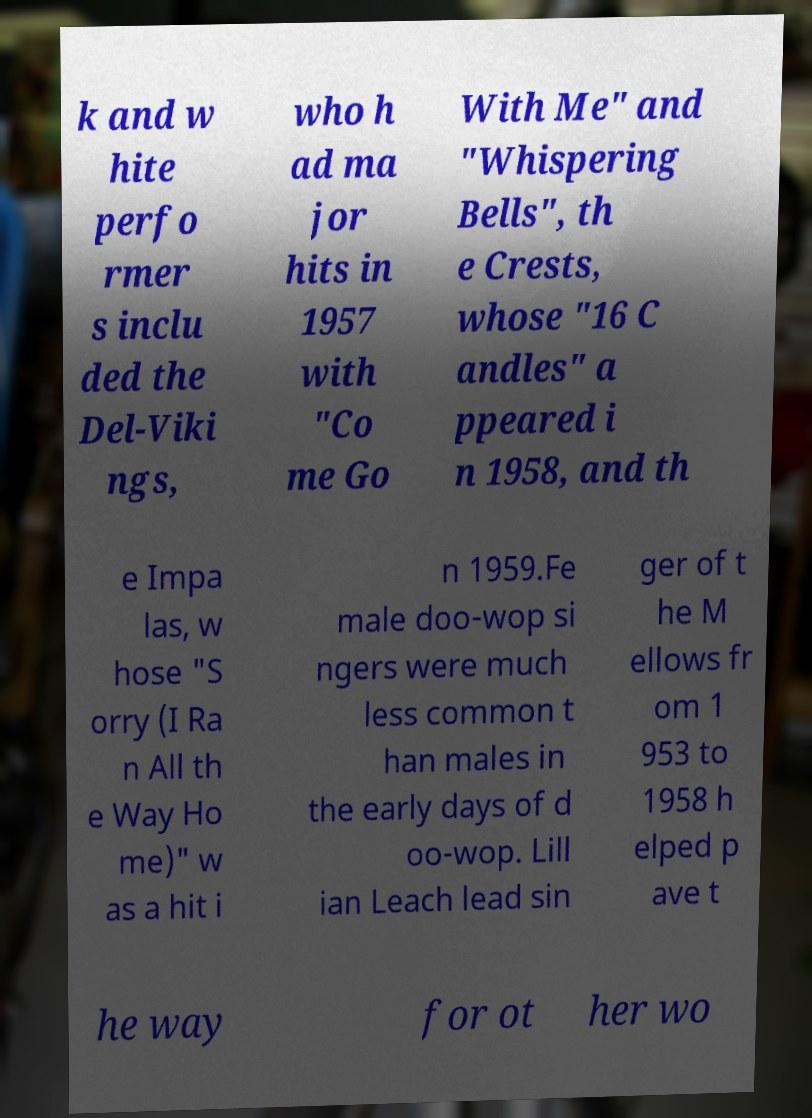Please identify and transcribe the text found in this image. k and w hite perfo rmer s inclu ded the Del-Viki ngs, who h ad ma jor hits in 1957 with "Co me Go With Me" and "Whispering Bells", th e Crests, whose "16 C andles" a ppeared i n 1958, and th e Impa las, w hose "S orry (I Ra n All th e Way Ho me)" w as a hit i n 1959.Fe male doo-wop si ngers were much less common t han males in the early days of d oo-wop. Lill ian Leach lead sin ger of t he M ellows fr om 1 953 to 1958 h elped p ave t he way for ot her wo 